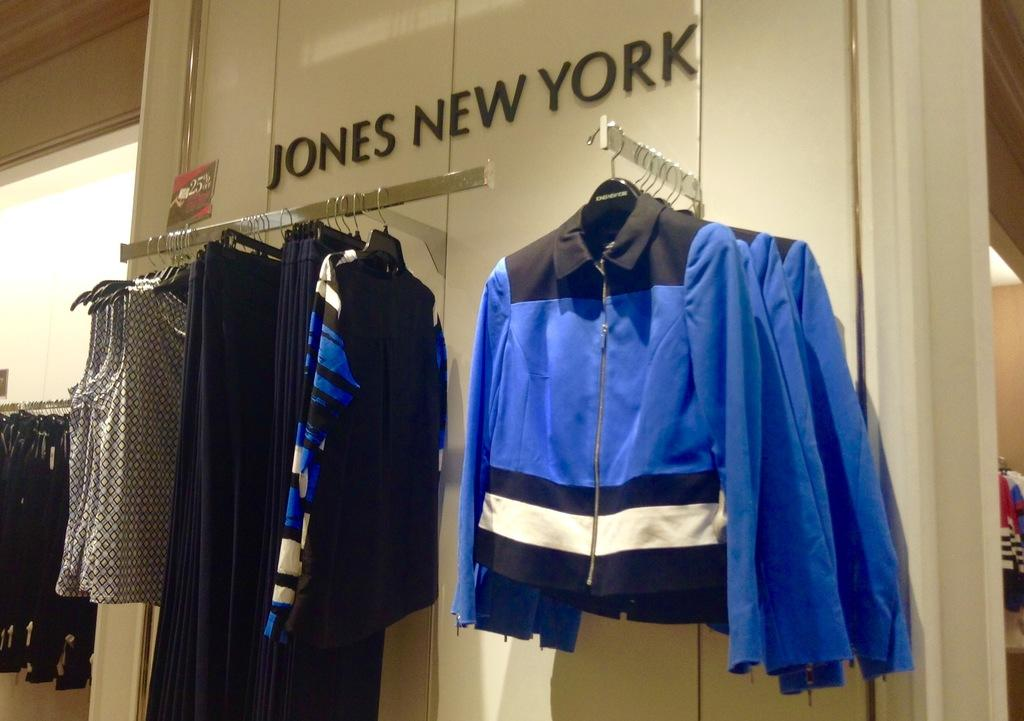<image>
Describe the image concisely. Store display of clothing below Jones New York letters. 